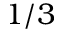Convert formula to latex. <formula><loc_0><loc_0><loc_500><loc_500>1 / 3</formula> 